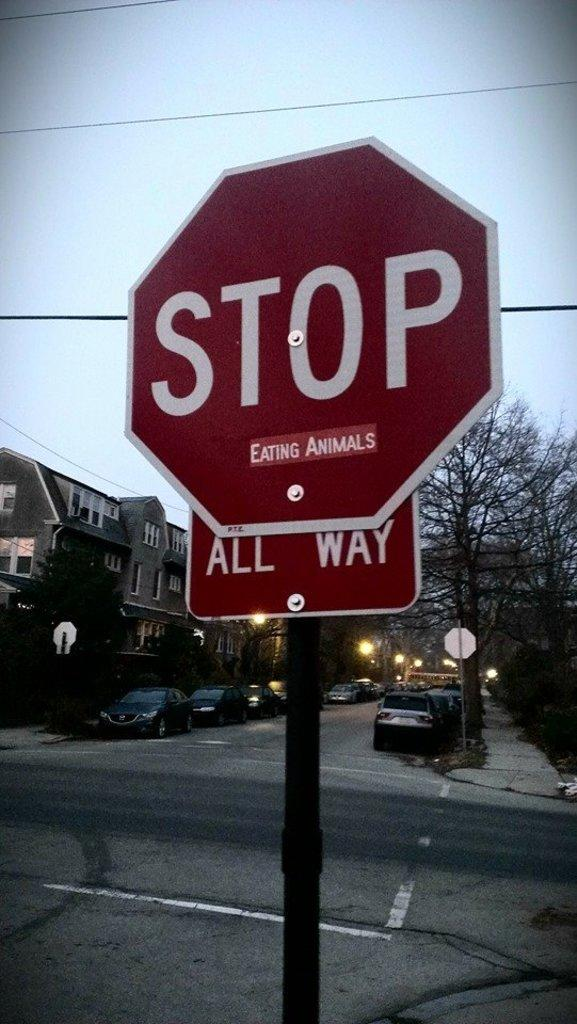Provide a one-sentence caption for the provided image. You must stop in all directions before proceeding through the intersection. 